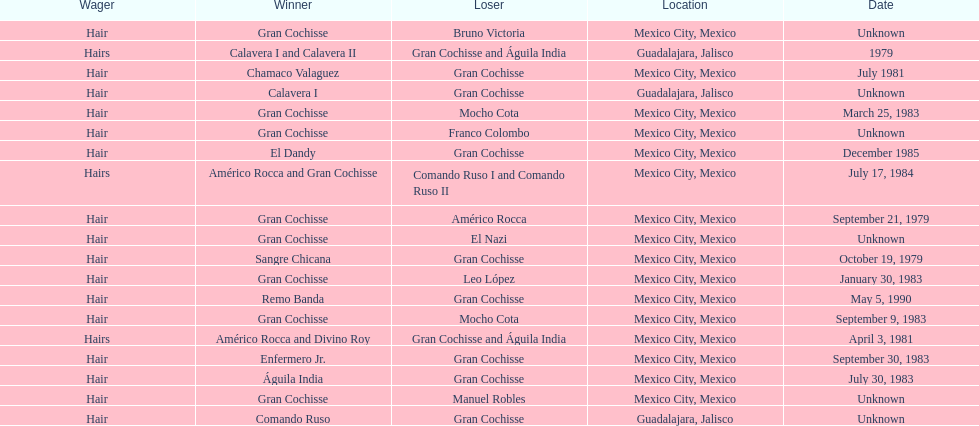When was gran chochisse first match that had a full date on record? September 21, 1979. 